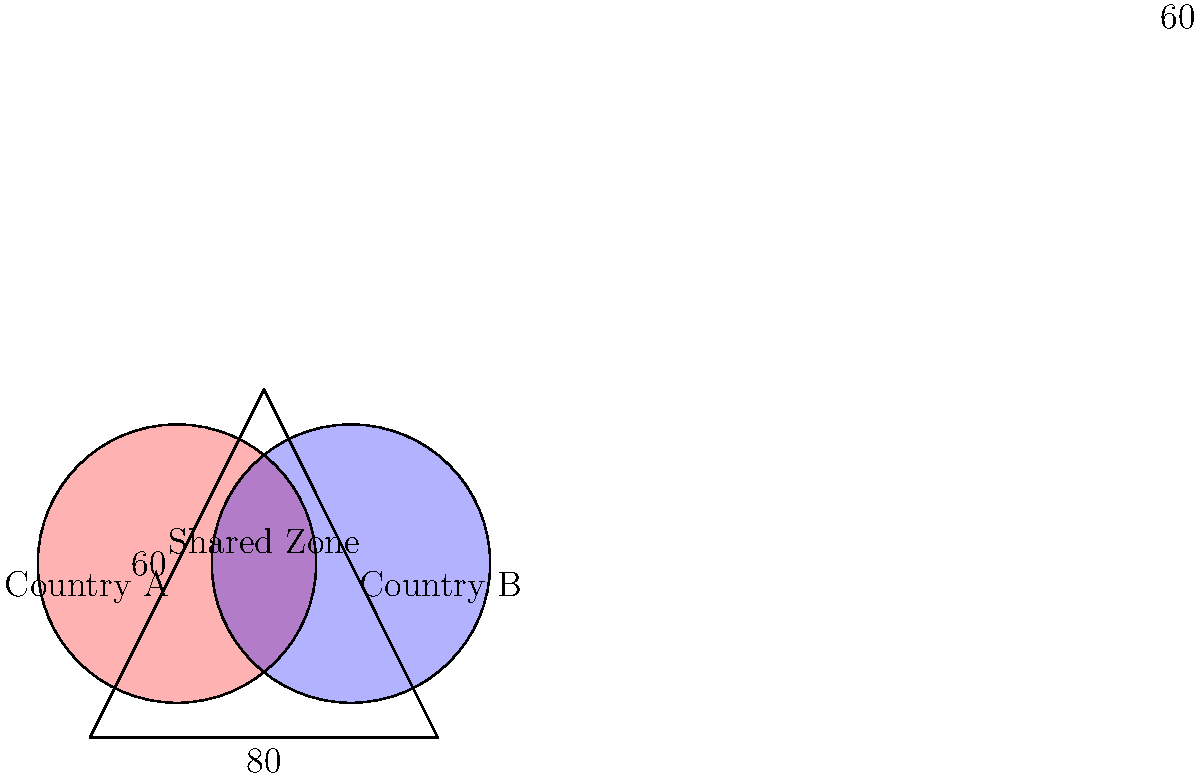In the Venn diagram representing overlapping economic zones between two countries, the total area enclosed by the triangle is 4000 square kilometers. If each circle represents an economic zone with a radius of 60 kilometers, what is the area of the shared economic zone (overlapping region) between Country A and Country B? Round your answer to the nearest whole number. To solve this problem, we need to follow these steps:

1) First, calculate the area of each circular economic zone:
   Area of a circle = $\pi r^2$
   $A = \pi (60)^2 = 3600\pi$ sq km

2) The total area of both circles combined:
   $3600\pi + 3600\pi = 7200\pi$ sq km

3) To find the overlapping area, we need to use the formula:
   Area of overlap = Area of Circle A + Area of Circle B - Area of Union

4) The Area of Union is the total area enclosed by both circles minus the area outside the triangle:
   Area of Union = $7200\pi - (7200\pi - 4000)$ = 4000 sq km

5) Now we can calculate the area of overlap:
   Area of overlap = $3600\pi + 3600\pi - 4000$
                   = $7200\pi - 4000$
                   = $22619.47 - 4000$
                   = 18619.47 sq km

6) Rounding to the nearest whole number:
   18619 sq km
Answer: 18619 sq km 